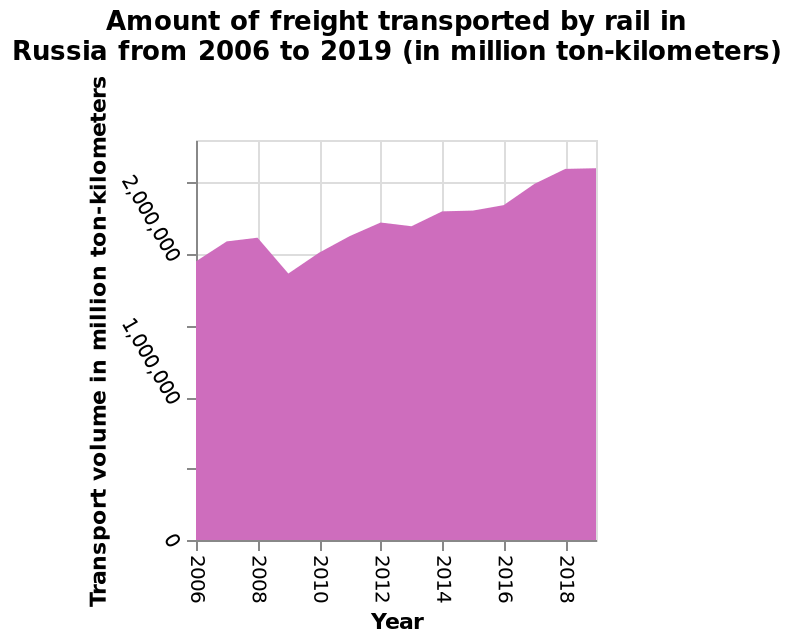<image>
please summary the statistics and relations of the chart Between 2006 and 2019 the amount of freight transported by rail in Russia has consistently increased year on year, with the exception of a modest decline in 2009, from just below 2,000,000 tonne kilometres to over 2,500,000. In which year did the amount of freight transported by rail in Russia experience a decline?  The amount of freight transported by rail in Russia experienced a modest decline in 2009. 